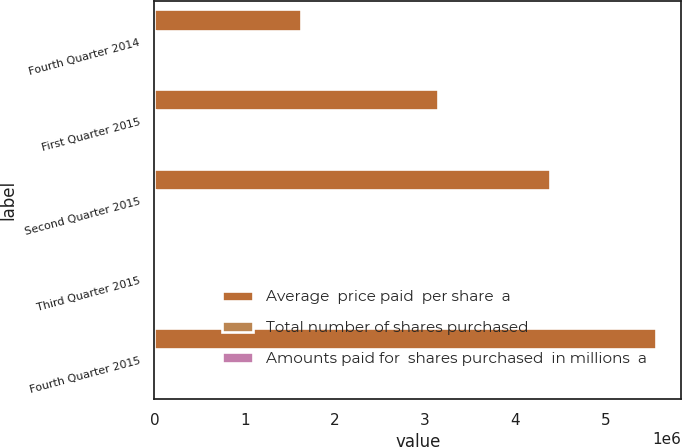Convert chart to OTSL. <chart><loc_0><loc_0><loc_500><loc_500><stacked_bar_chart><ecel><fcel>Fourth Quarter 2014<fcel>First Quarter 2015<fcel>Second Quarter 2015<fcel>Third Quarter 2015<fcel>Fourth Quarter 2015<nl><fcel>Average  price paid  per share  a<fcel>1.62436e+06<fcel>3.14648e+06<fcel>4.37991e+06<fcel>81.5<fcel>5.55892e+06<nl><fcel>Total number of shares purchased<fcel>26.95<fcel>25.15<fcel>24.53<fcel>15.06<fcel>15.03<nl><fcel>Amounts paid for  shares purchased  in millions  a<fcel>44<fcel>79<fcel>107<fcel>167<fcel>84<nl></chart> 